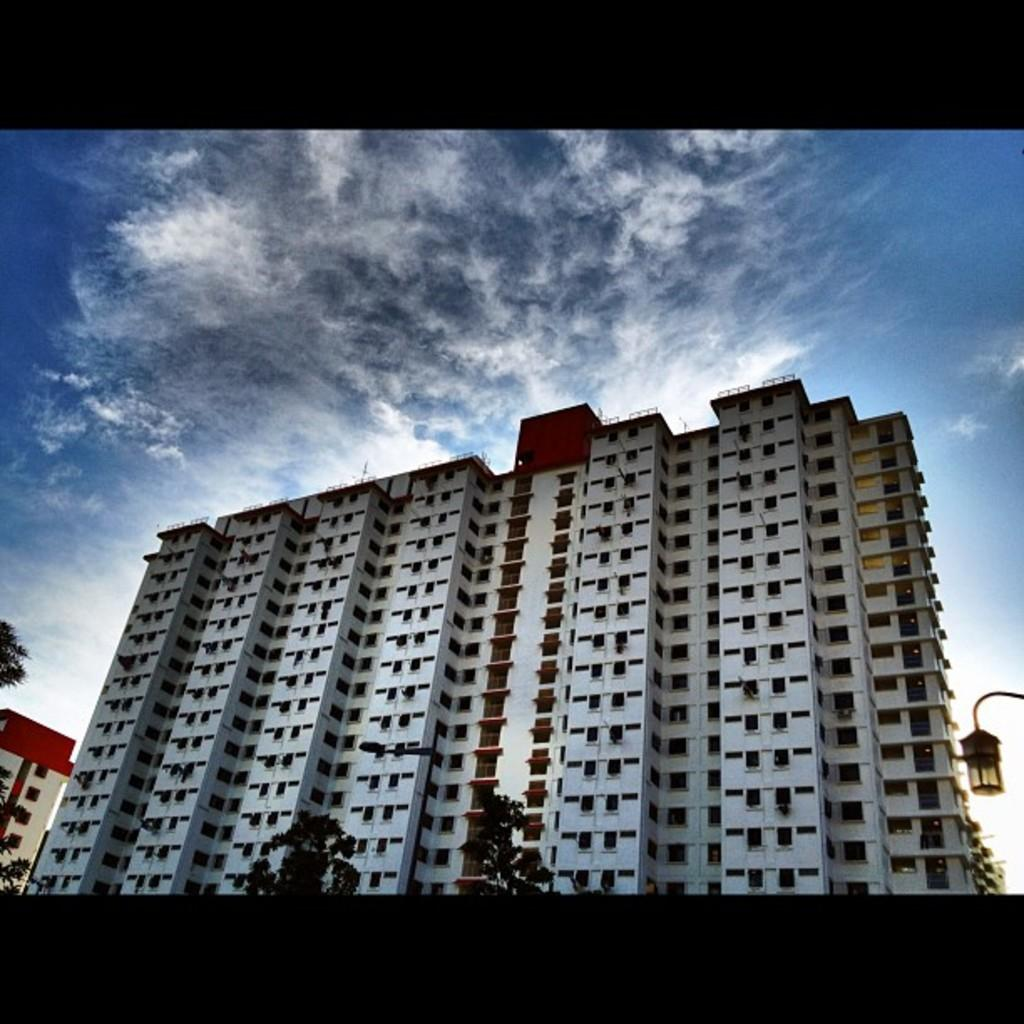What type of structures are present in the image? There are buildings with windows in the image. What is the tall, vertical object in the image? There is a light pole in the image. What type of vegetation is visible in the image? There are plants in the image. What can be seen in the distance in the image? The sky is visible in the background of the image. What type of show is being performed by the dolls in the image? There are no dolls present in the image, so it is not possible to determine if a show is being performed. 